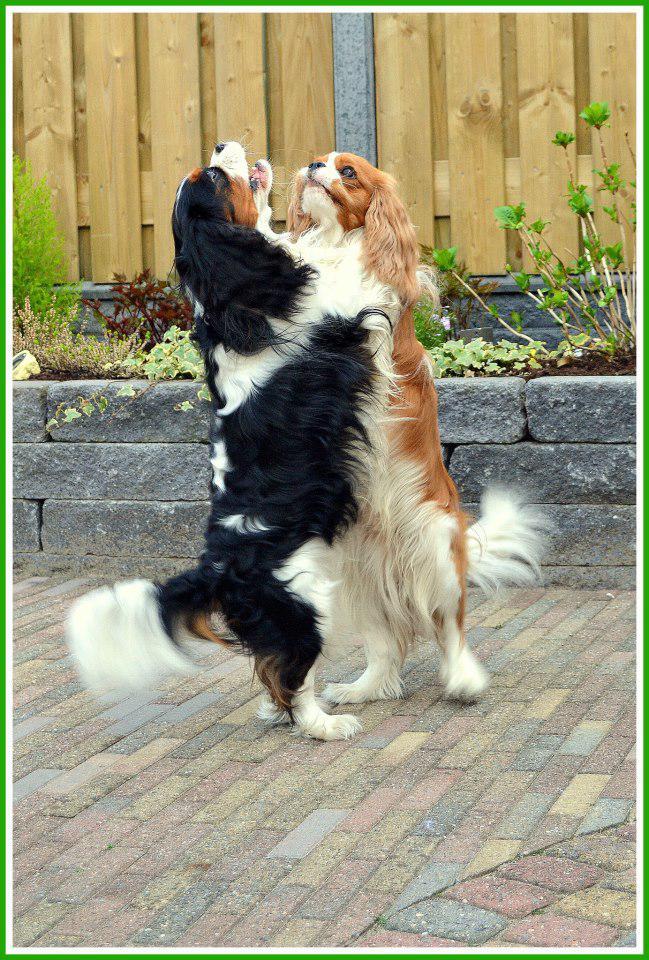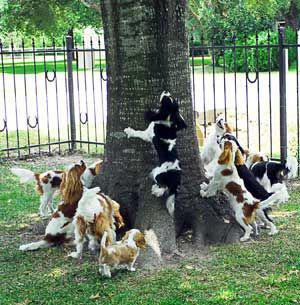The first image is the image on the left, the second image is the image on the right. For the images shown, is this caption "There are more spaniels with brown ears than spaniels with black ears." true? Answer yes or no. Yes. The first image is the image on the left, the second image is the image on the right. Examine the images to the left and right. Is the description "At least one of the dogs is not standing on grass." accurate? Answer yes or no. Yes. 